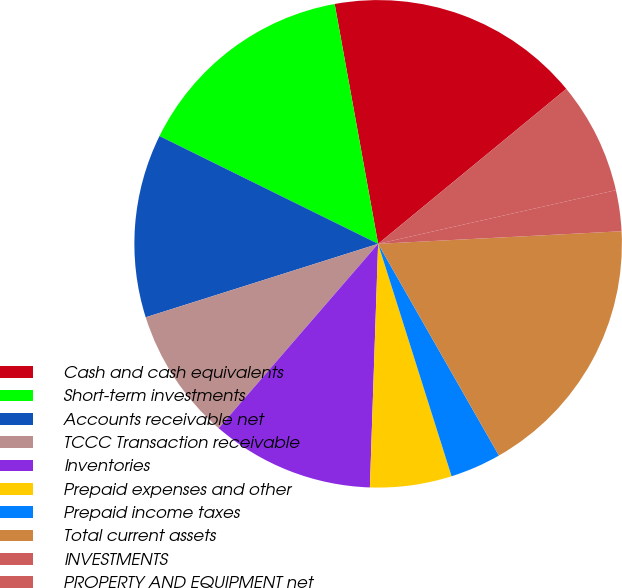Convert chart to OTSL. <chart><loc_0><loc_0><loc_500><loc_500><pie_chart><fcel>Cash and cash equivalents<fcel>Short-term investments<fcel>Accounts receivable net<fcel>TCCC Transaction receivable<fcel>Inventories<fcel>Prepaid expenses and other<fcel>Prepaid income taxes<fcel>Total current assets<fcel>INVESTMENTS<fcel>PROPERTY AND EQUIPMENT net<nl><fcel>16.89%<fcel>14.86%<fcel>12.16%<fcel>8.78%<fcel>10.81%<fcel>5.41%<fcel>3.38%<fcel>17.57%<fcel>2.71%<fcel>7.43%<nl></chart> 